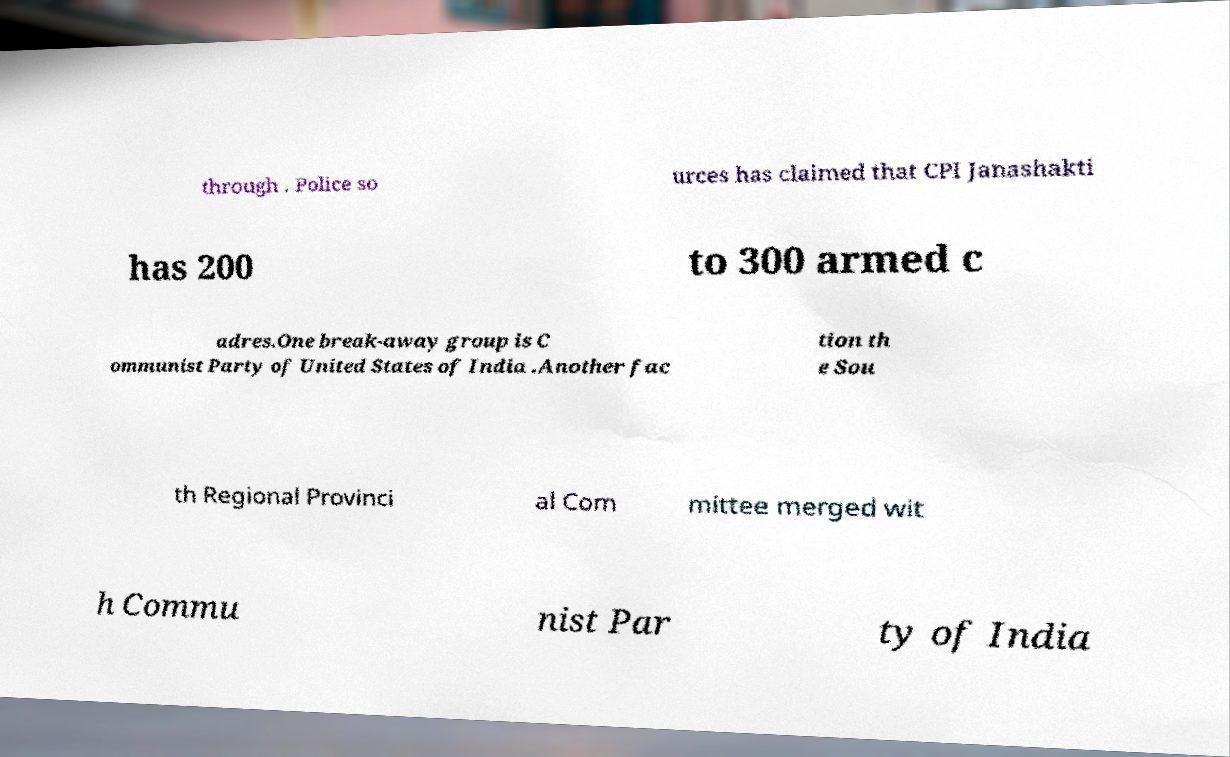Could you assist in decoding the text presented in this image and type it out clearly? through . Police so urces has claimed that CPI Janashakti has 200 to 300 armed c adres.One break-away group is C ommunist Party of United States of India .Another fac tion th e Sou th Regional Provinci al Com mittee merged wit h Commu nist Par ty of India 